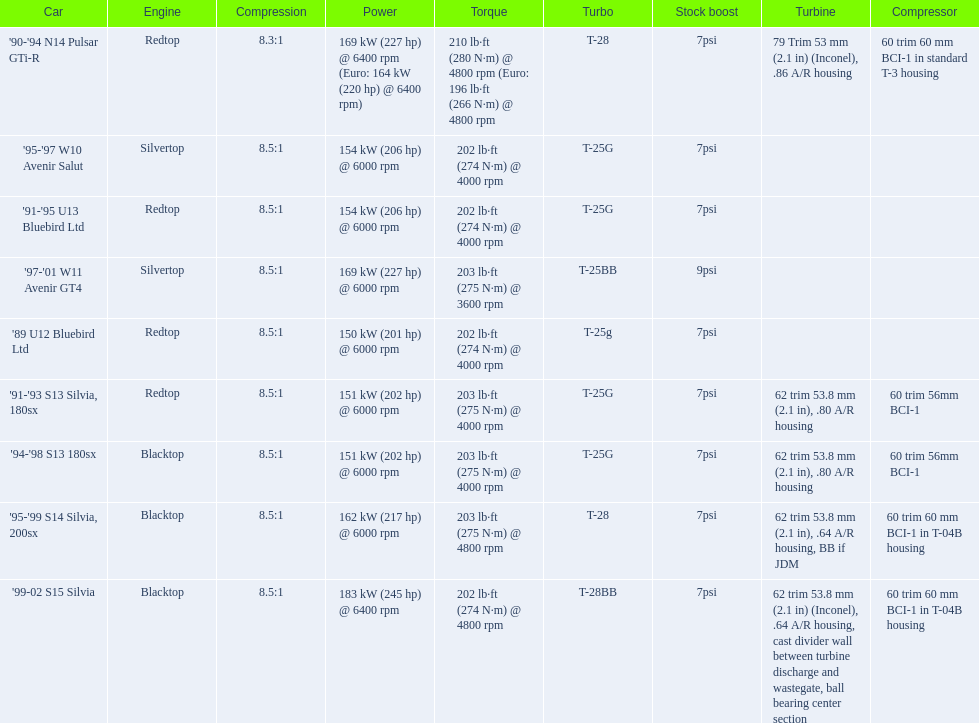What are the psi's? 7psi, 7psi, 7psi, 9psi, 7psi, 7psi, 7psi, 7psi, 7psi. What are the number(s) greater than 7? 9psi. Which car has that number? '97-'01 W11 Avenir GT4. 